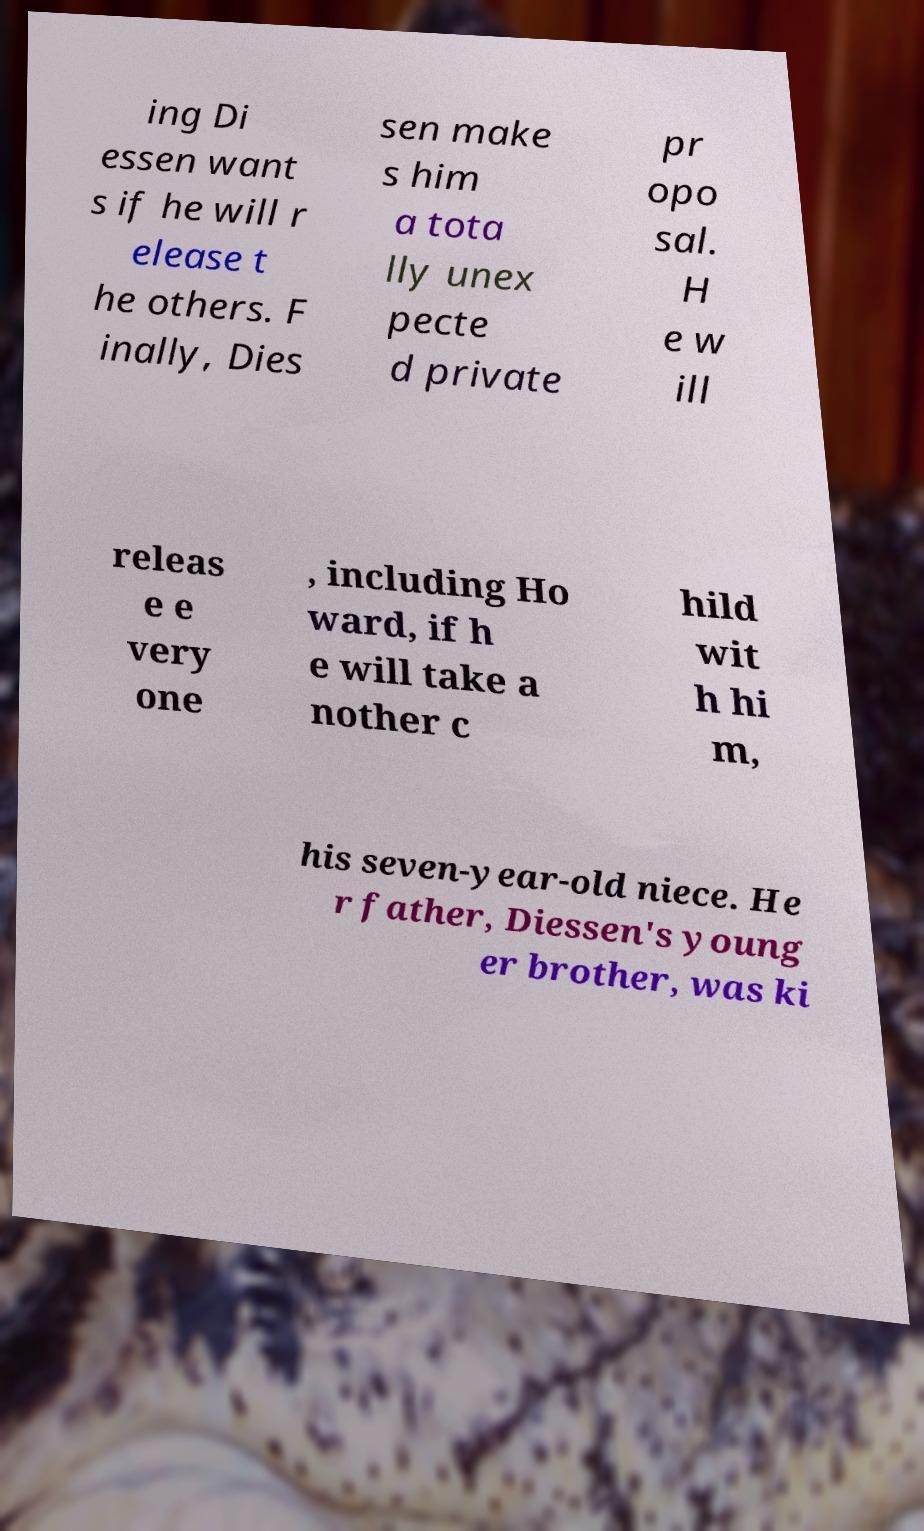What messages or text are displayed in this image? I need them in a readable, typed format. ing Di essen want s if he will r elease t he others. F inally, Dies sen make s him a tota lly unex pecte d private pr opo sal. H e w ill releas e e very one , including Ho ward, if h e will take a nother c hild wit h hi m, his seven-year-old niece. He r father, Diessen's young er brother, was ki 